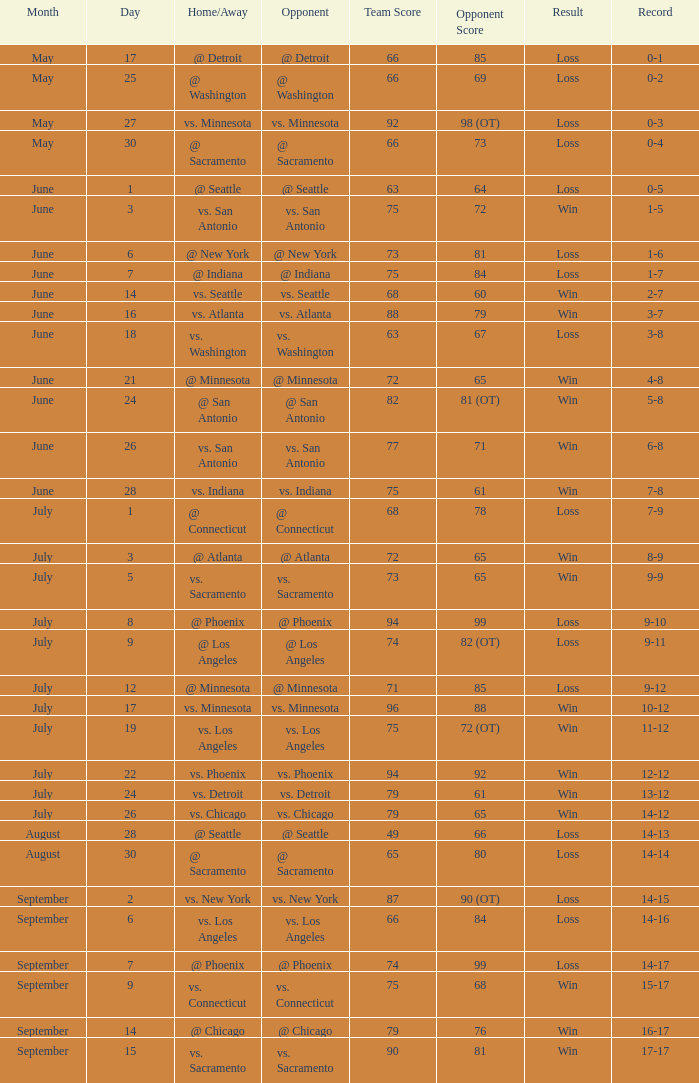What was the Result on July 24? Win. 